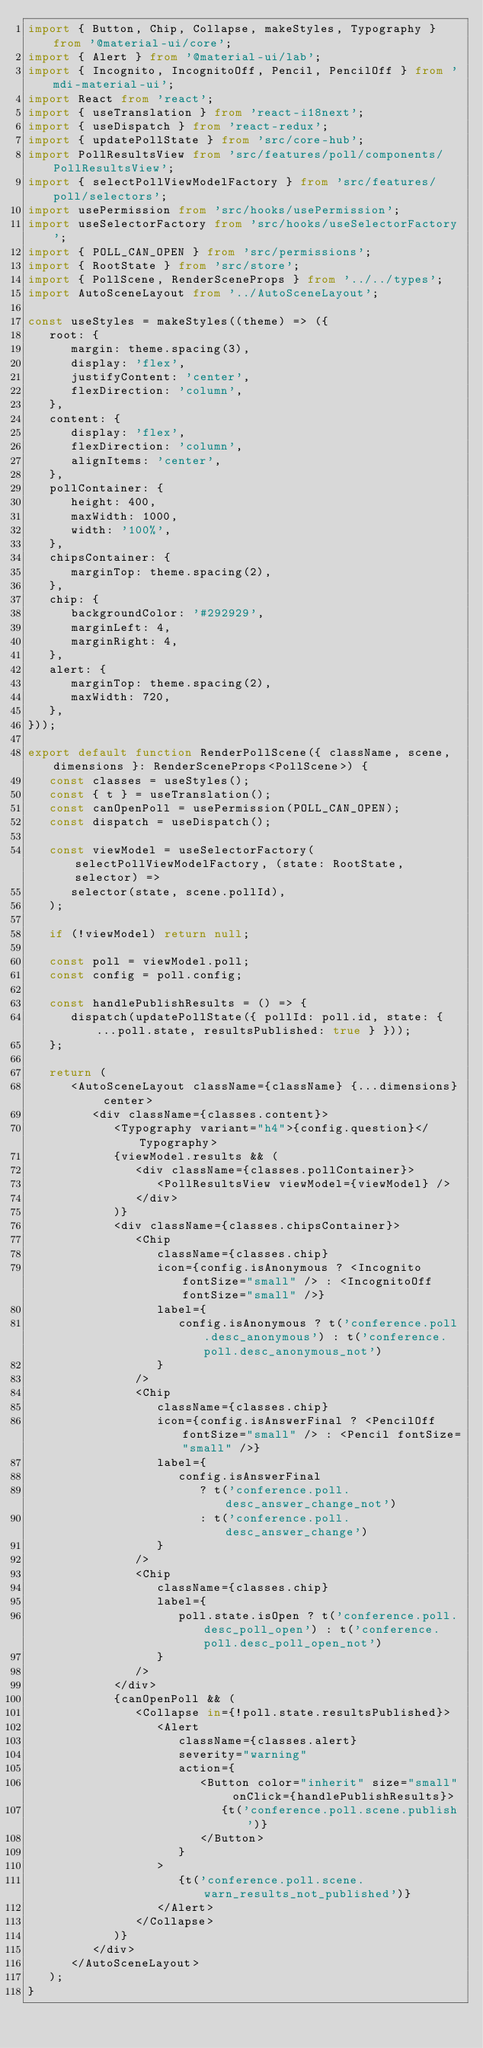Convert code to text. <code><loc_0><loc_0><loc_500><loc_500><_TypeScript_>import { Button, Chip, Collapse, makeStyles, Typography } from '@material-ui/core';
import { Alert } from '@material-ui/lab';
import { Incognito, IncognitoOff, Pencil, PencilOff } from 'mdi-material-ui';
import React from 'react';
import { useTranslation } from 'react-i18next';
import { useDispatch } from 'react-redux';
import { updatePollState } from 'src/core-hub';
import PollResultsView from 'src/features/poll/components/PollResultsView';
import { selectPollViewModelFactory } from 'src/features/poll/selectors';
import usePermission from 'src/hooks/usePermission';
import useSelectorFactory from 'src/hooks/useSelectorFactory';
import { POLL_CAN_OPEN } from 'src/permissions';
import { RootState } from 'src/store';
import { PollScene, RenderSceneProps } from '../../types';
import AutoSceneLayout from '../AutoSceneLayout';

const useStyles = makeStyles((theme) => ({
   root: {
      margin: theme.spacing(3),
      display: 'flex',
      justifyContent: 'center',
      flexDirection: 'column',
   },
   content: {
      display: 'flex',
      flexDirection: 'column',
      alignItems: 'center',
   },
   pollContainer: {
      height: 400,
      maxWidth: 1000,
      width: '100%',
   },
   chipsContainer: {
      marginTop: theme.spacing(2),
   },
   chip: {
      backgroundColor: '#292929',
      marginLeft: 4,
      marginRight: 4,
   },
   alert: {
      marginTop: theme.spacing(2),
      maxWidth: 720,
   },
}));

export default function RenderPollScene({ className, scene, dimensions }: RenderSceneProps<PollScene>) {
   const classes = useStyles();
   const { t } = useTranslation();
   const canOpenPoll = usePermission(POLL_CAN_OPEN);
   const dispatch = useDispatch();

   const viewModel = useSelectorFactory(selectPollViewModelFactory, (state: RootState, selector) =>
      selector(state, scene.pollId),
   );

   if (!viewModel) return null;

   const poll = viewModel.poll;
   const config = poll.config;

   const handlePublishResults = () => {
      dispatch(updatePollState({ pollId: poll.id, state: { ...poll.state, resultsPublished: true } }));
   };

   return (
      <AutoSceneLayout className={className} {...dimensions} center>
         <div className={classes.content}>
            <Typography variant="h4">{config.question}</Typography>
            {viewModel.results && (
               <div className={classes.pollContainer}>
                  <PollResultsView viewModel={viewModel} />
               </div>
            )}
            <div className={classes.chipsContainer}>
               <Chip
                  className={classes.chip}
                  icon={config.isAnonymous ? <Incognito fontSize="small" /> : <IncognitoOff fontSize="small" />}
                  label={
                     config.isAnonymous ? t('conference.poll.desc_anonymous') : t('conference.poll.desc_anonymous_not')
                  }
               />
               <Chip
                  className={classes.chip}
                  icon={config.isAnswerFinal ? <PencilOff fontSize="small" /> : <Pencil fontSize="small" />}
                  label={
                     config.isAnswerFinal
                        ? t('conference.poll.desc_answer_change_not')
                        : t('conference.poll.desc_answer_change')
                  }
               />
               <Chip
                  className={classes.chip}
                  label={
                     poll.state.isOpen ? t('conference.poll.desc_poll_open') : t('conference.poll.desc_poll_open_not')
                  }
               />
            </div>
            {canOpenPoll && (
               <Collapse in={!poll.state.resultsPublished}>
                  <Alert
                     className={classes.alert}
                     severity="warning"
                     action={
                        <Button color="inherit" size="small" onClick={handlePublishResults}>
                           {t('conference.poll.scene.publish')}
                        </Button>
                     }
                  >
                     {t('conference.poll.scene.warn_results_not_published')}
                  </Alert>
               </Collapse>
            )}
         </div>
      </AutoSceneLayout>
   );
}
</code> 